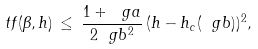<formula> <loc_0><loc_0><loc_500><loc_500>\ t f ( \beta , h ) \, \leq \, \frac { 1 + \ g a } { 2 \ g b ^ { 2 } } \, ( h - h _ { c } ( \ g b ) ) ^ { 2 } ,</formula> 